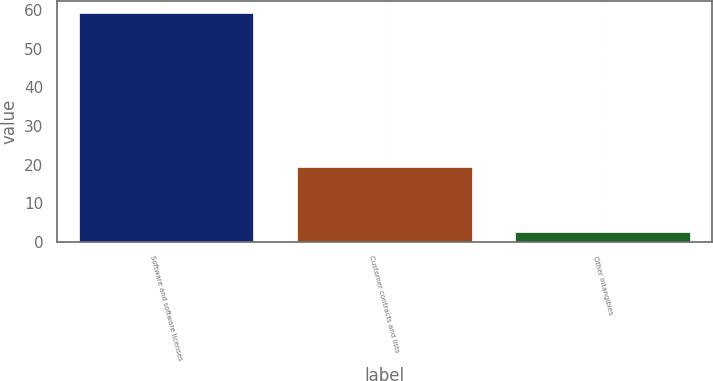Convert chart. <chart><loc_0><loc_0><loc_500><loc_500><bar_chart><fcel>Software and software licenses<fcel>Customer contracts and lists<fcel>Other intangibles<nl><fcel>59.3<fcel>19.5<fcel>2.5<nl></chart> 